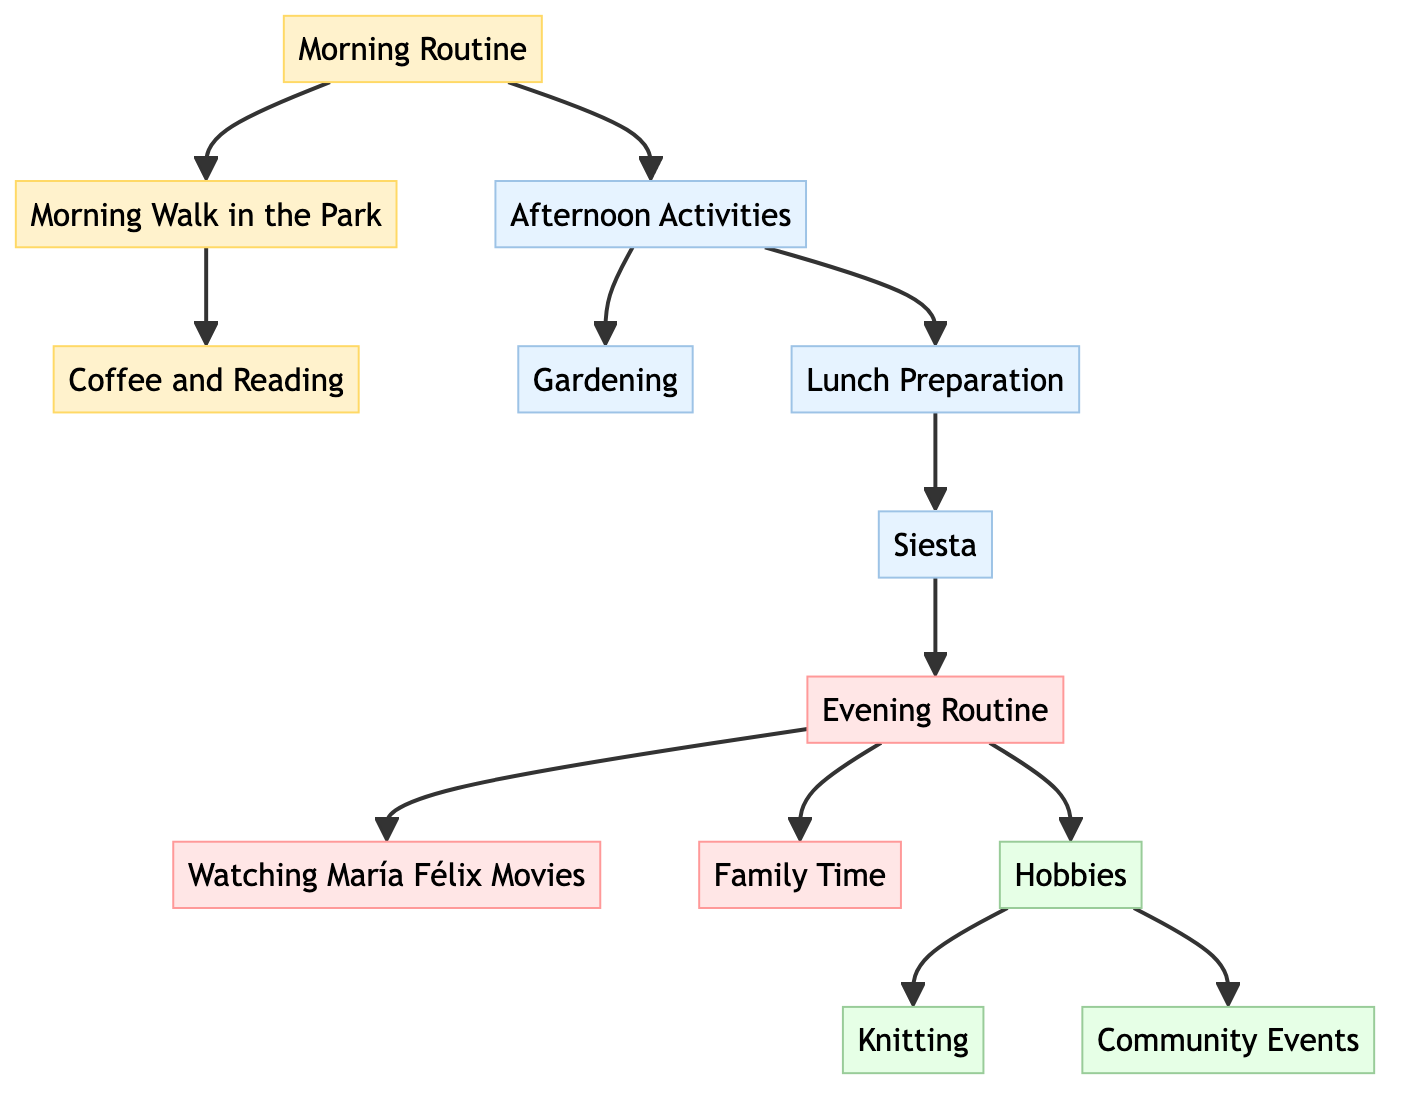What is the first activity in the morning routine? The first activity listed in the diagram under the morning routine is "Morning Walk in the Park," which immediately follows the "Morning Routine" node.
Answer: Morning Walk in the Park How many activities are there in the evening routine? The evening routine has three connected activities: "Watching María Félix Movies," "Family Time," and "Hobbies." Therefore, the total count of activities is three.
Answer: 3 What activities follow after "Lunch Preparation"? The diagram shows that "Siesta" follows "Lunch Preparation," indicating that the next activity after preparing lunch is to take a siesta.
Answer: Siesta Which hobby is directly connected to the "Hobbies" node? According to the diagram, "Knitting" and "Community Events" are both directly connected to the "Hobbies" node. This indicates they are the two hobbies included in that category.
Answer: Knitting, Community Events What are the transitions from "Siesta" in the daily routine? The flow in the diagram shows that after "Siesta," the next activity is "Evening Routine," indicating there are direct transitions from "Siesta" to "Evening Routine."
Answer: Evening Routine Which task is associated with both morning and afternoon? The diagram indicates that "Afternoon Activities" follows directly from the "Morning Routine," establishing a connection between these two periods in the daily routine.
Answer: Afternoon Activities How are "Walking" and "Coffee and Reading" connected? The relationship established in the diagram shows that "Walking" directly leads to "Coffee and Reading," meaning after walking, the next task is reading while having coffee.
Answer: Coffee and Reading What activities occur after "Afternoon Activities"? The diagram shows that activities "Gardening" and "Lunch Preparation" directly follow "Afternoon Activities," providing two options after completing the afternoon stage.
Answer: Gardening, Lunch Preparation 